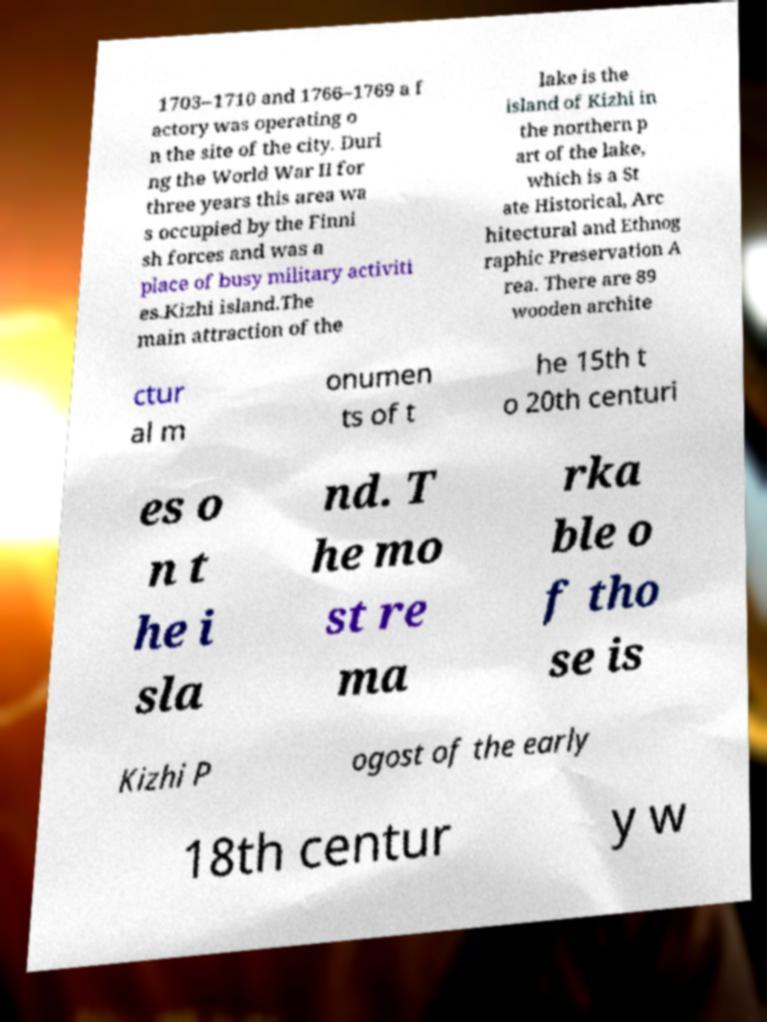Could you assist in decoding the text presented in this image and type it out clearly? 1703–1710 and 1766–1769 a f actory was operating o n the site of the city. Duri ng the World War II for three years this area wa s occupied by the Finni sh forces and was a place of busy military activiti es.Kizhi island.The main attraction of the lake is the island of Kizhi in the northern p art of the lake, which is a St ate Historical, Arc hitectural and Ethnog raphic Preservation A rea. There are 89 wooden archite ctur al m onumen ts of t he 15th t o 20th centuri es o n t he i sla nd. T he mo st re ma rka ble o f tho se is Kizhi P ogost of the early 18th centur y w 